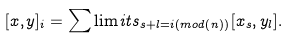<formula> <loc_0><loc_0><loc_500><loc_500>[ x , y ] _ { i } = \sum \lim i t s _ { s + l = i ( m o d ( n ) ) } [ x _ { s } , y _ { l } ] .</formula> 